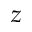<formula> <loc_0><loc_0><loc_500><loc_500>z</formula> 